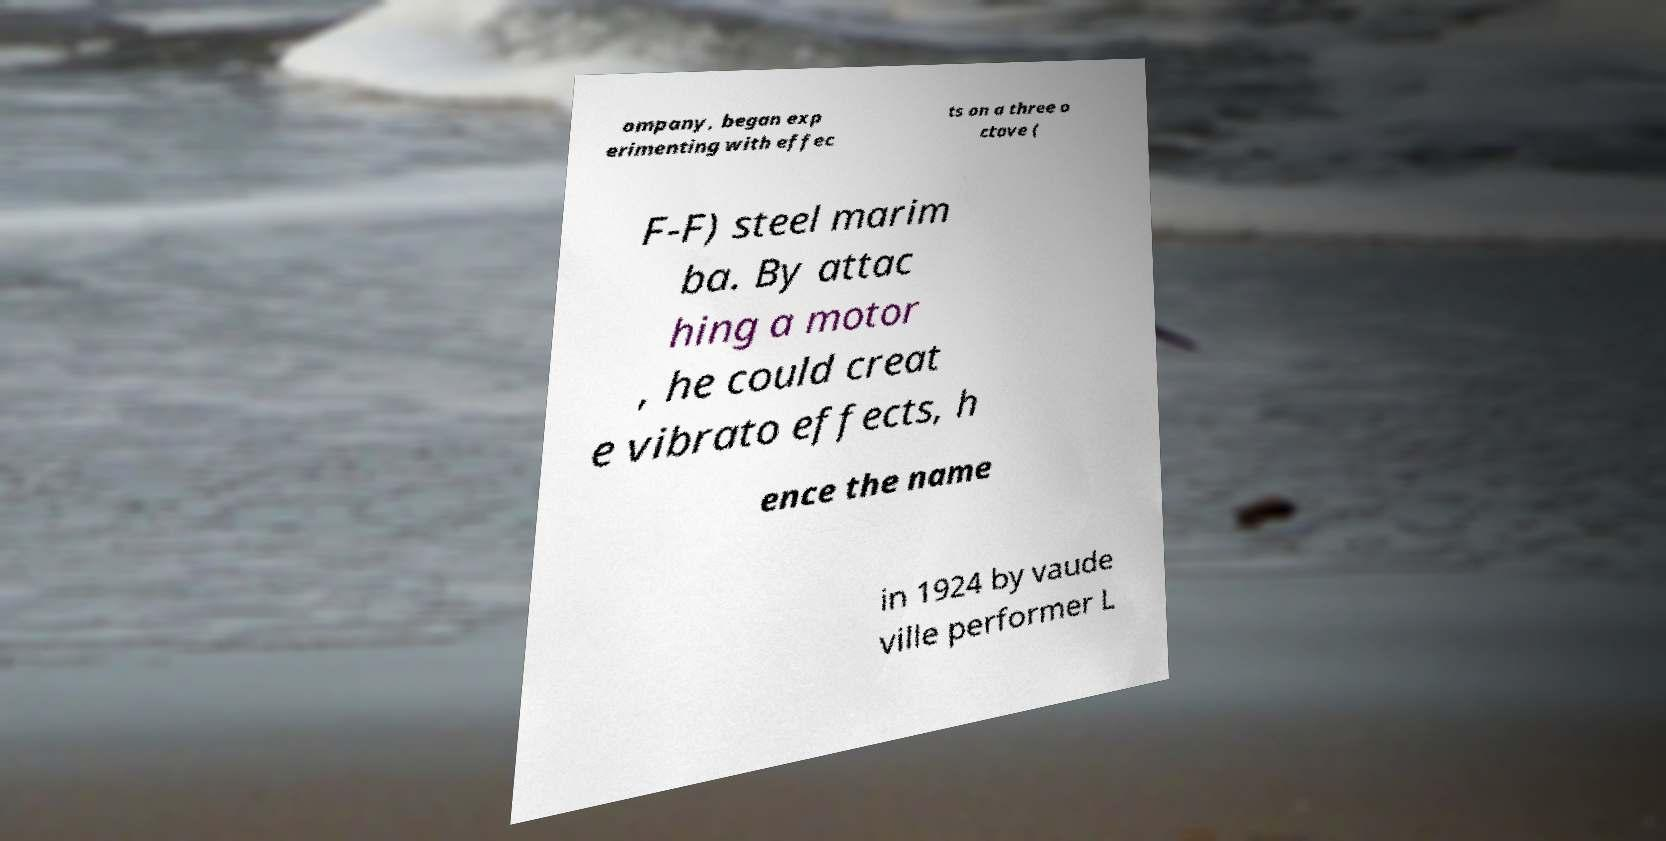There's text embedded in this image that I need extracted. Can you transcribe it verbatim? ompany, began exp erimenting with effec ts on a three o ctave ( F-F) steel marim ba. By attac hing a motor , he could creat e vibrato effects, h ence the name in 1924 by vaude ville performer L 